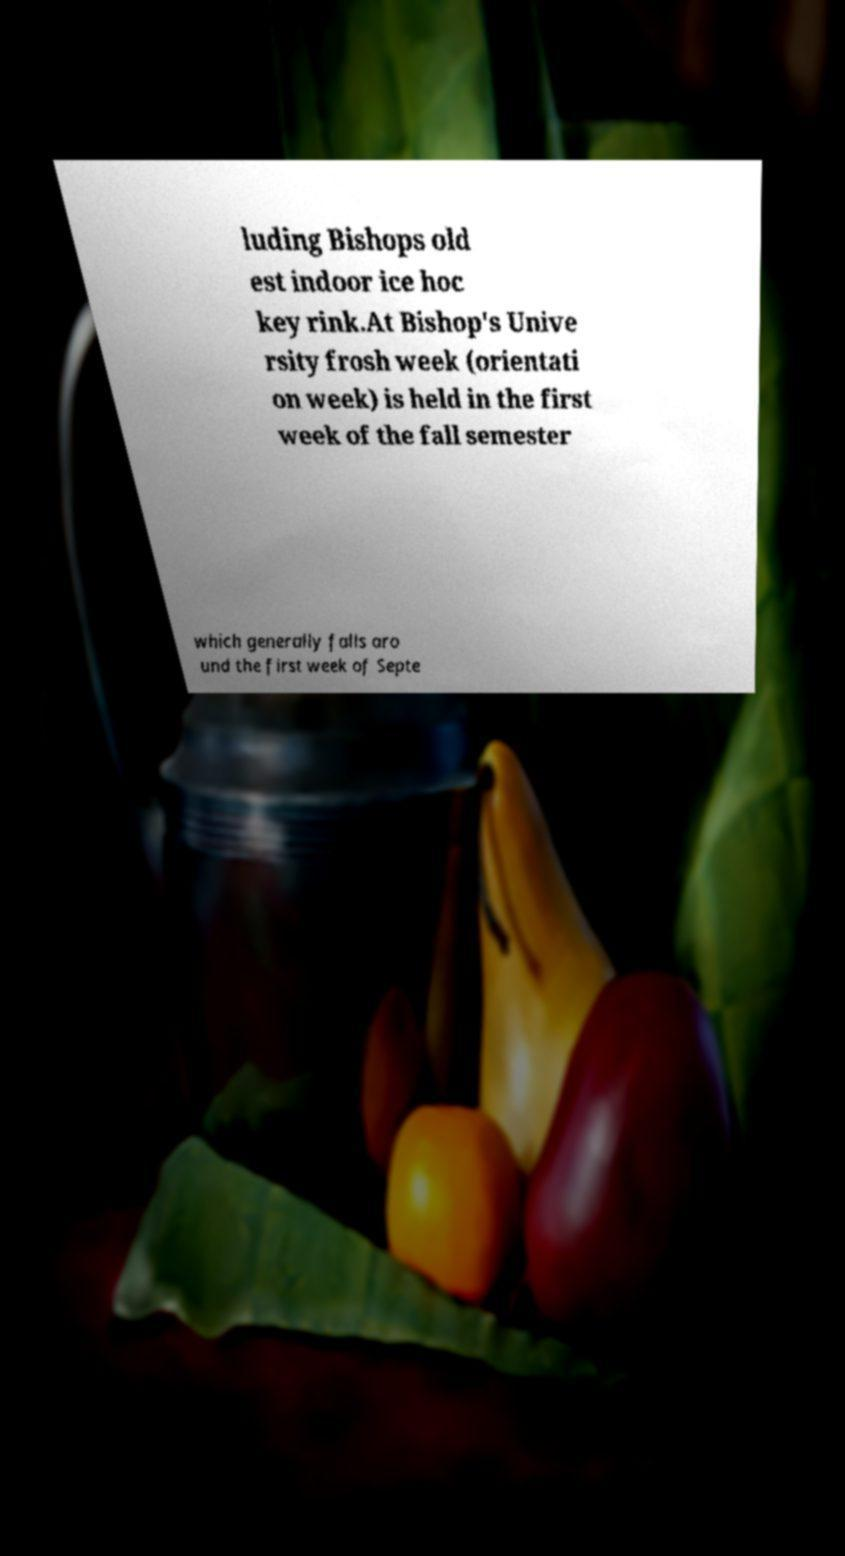I need the written content from this picture converted into text. Can you do that? luding Bishops old est indoor ice hoc key rink.At Bishop's Unive rsity frosh week (orientati on week) is held in the first week of the fall semester which generally falls aro und the first week of Septe 